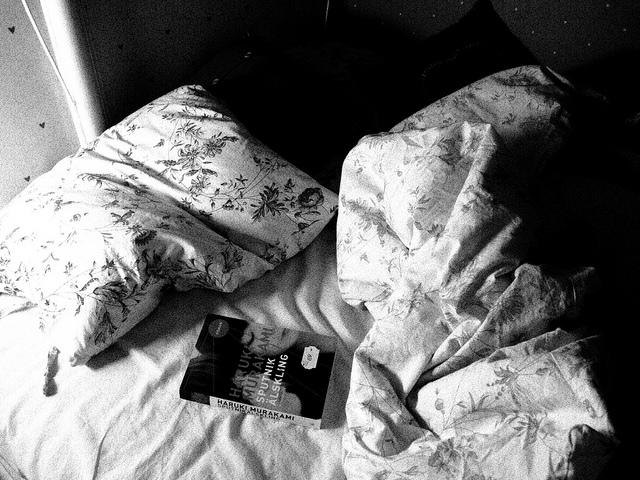Is the bed made?
Write a very short answer. No. What is the title of this book?
Answer briefly. Sputnik alskling. Does the object on the bed contain printed words?
Short answer required. Yes. 